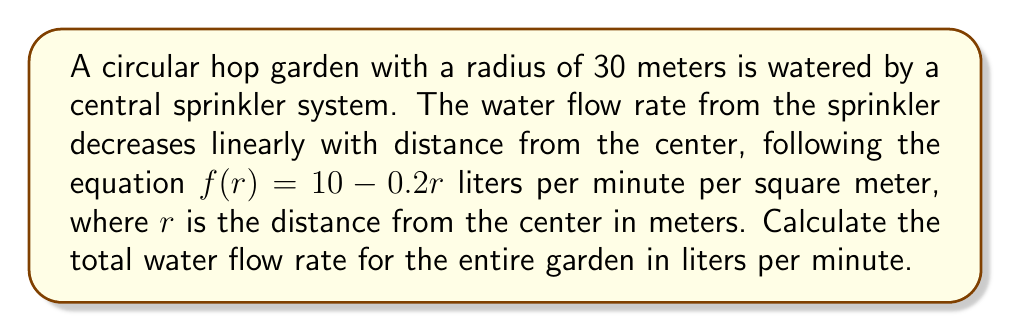Can you solve this math problem? To solve this problem, we need to use polar coordinates and integration. Let's break it down step-by-step:

1) The water flow rate is given by $f(r) = 10 - 0.2r$ liters per minute per square meter.

2) To find the total water flow rate, we need to integrate this function over the entire circular area.

3) In polar coordinates, the area element is given by $dA = r dr d\theta$.

4) The total flow rate can be calculated using the double integral:

   $$\int_0^{2\pi} \int_0^{30} f(r) \cdot r \, dr \, d\theta$$

5) Substituting the function:

   $$\int_0^{2\pi} \int_0^{30} (10 - 0.2r) \cdot r \, dr \, d\theta$$

6) Let's solve the inner integral first:

   $$\int_0^{30} (10r - 0.2r^2) \, dr = \left[5r^2 - \frac{1}{15}r^3\right]_0^{30}$$

7) Evaluating the limits:

   $$\left(5(30^2) - \frac{1}{15}(30^3)\right) - \left(5(0^2) - \frac{1}{15}(0^3)\right) = 4500 - 1800 = 2700$$

8) Now, we integrate with respect to $\theta$:

   $$\int_0^{2\pi} 2700 \, d\theta = 2700 \cdot 2\pi = 5400\pi$$

Therefore, the total water flow rate for the entire garden is $5400\pi$ liters per minute.
Answer: $5400\pi$ liters per minute 